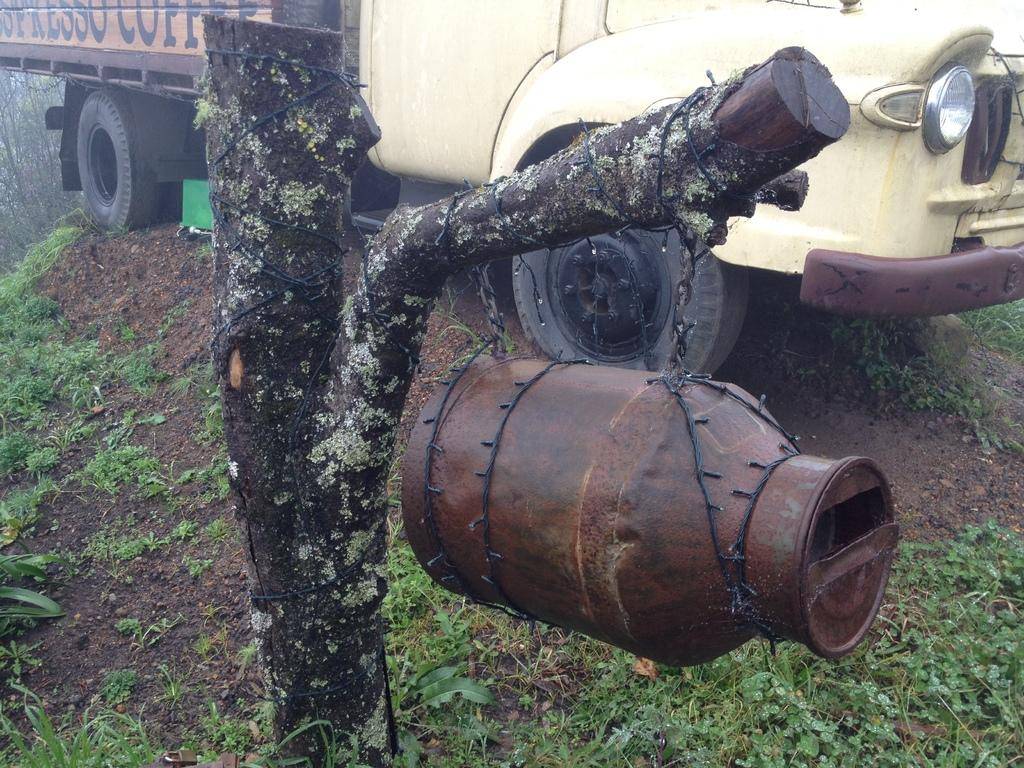What type of object is the wooden trunk in the image? There is a wooden trunk in the image. What else can be seen in the image besides the wooden trunk? There is a can and a truck in the image. What can be seen in the background of the image? Trees are present in the background of the image. What date is circled on the calendar in the image? There is no calendar present in the image. 